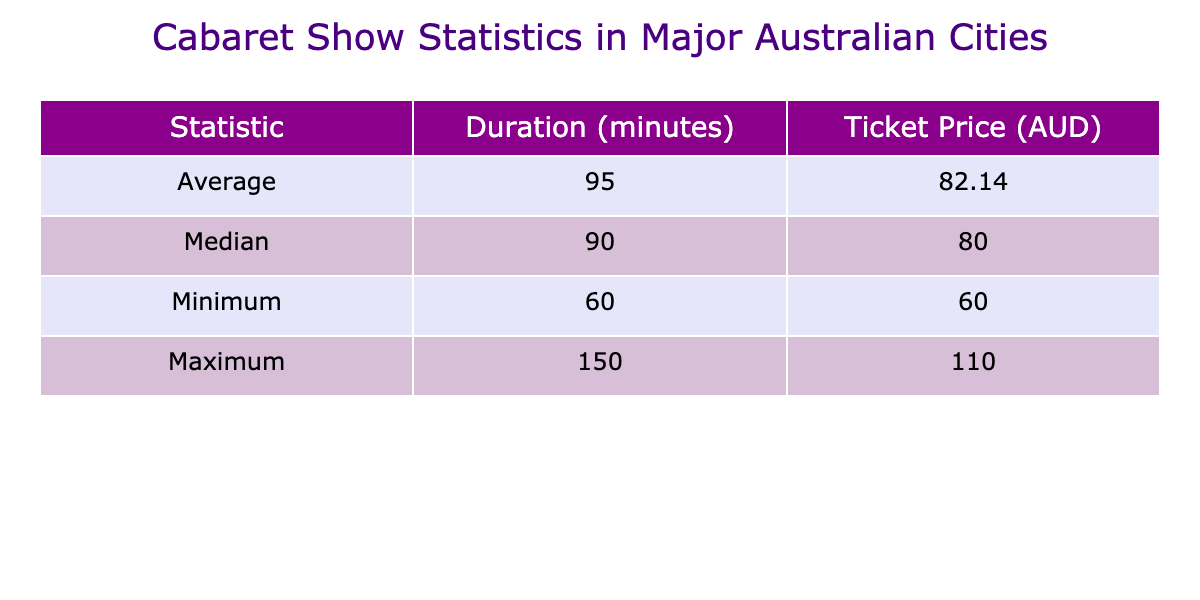What is the average duration of cabaret shows? To find the average duration, sum the durations of all shows: 90 + 120 + 75 + 60 + 150 + 80 + 90 = 665 minutes. Then divide by the number of shows (7): 665 / 7 = approximately 95 minutes.
Answer: 95 minutes Which city has the longest cabaret show duration? The maximum value in the duration column is 150 minutes, which belongs to Adelaide for the show "Cabaret Classics".
Answer: Adelaide What is the median ticket price of the shows listed? To find the median price, first arrange the ticket prices in order: 60, 70, 75, 80, 85, 95, 110. Since there are 7 values, the median is the fourth value, which is 80.
Answer: 80 AUD Is the ticket price for the longest show higher than the average ticket price? The longest show is in Adelaide with a ticket price of 110 AUD. The average ticket price is calculated as (85 + 95 + 70 + 60 + 110 + 80 + 75) / 7 = approximately 80.71. Since 110 > 80.71, the statement is true.
Answer: Yes How much longer is the longest show than the shortest show? The longest show duration is 150 minutes for Adelaide and the shortest is 60 minutes for Perth. The difference is 150 - 60 = 90 minutes.
Answer: 90 minutes What is the total duration of all shows recorded? Add all the durations together: 90 + 120 + 75 + 60 + 150 + 80 + 90 = 665 minutes.
Answer: 665 minutes Is there a show that costs less than 70 AUD? The prices listed are 60, 70, 75, 80, 85, 95, and 110 AUD. The show in Perth costs 60 AUD, which is less than 70 AUD. Therefore, the statement is true.
Answer: Yes Which city's show has a duration of 90 minutes and what is its ticket price? The show with 90 minutes duration is in Sydney titled "La Femme" and it has a ticket price of 85 AUD.
Answer: Sydney, 85 AUD 